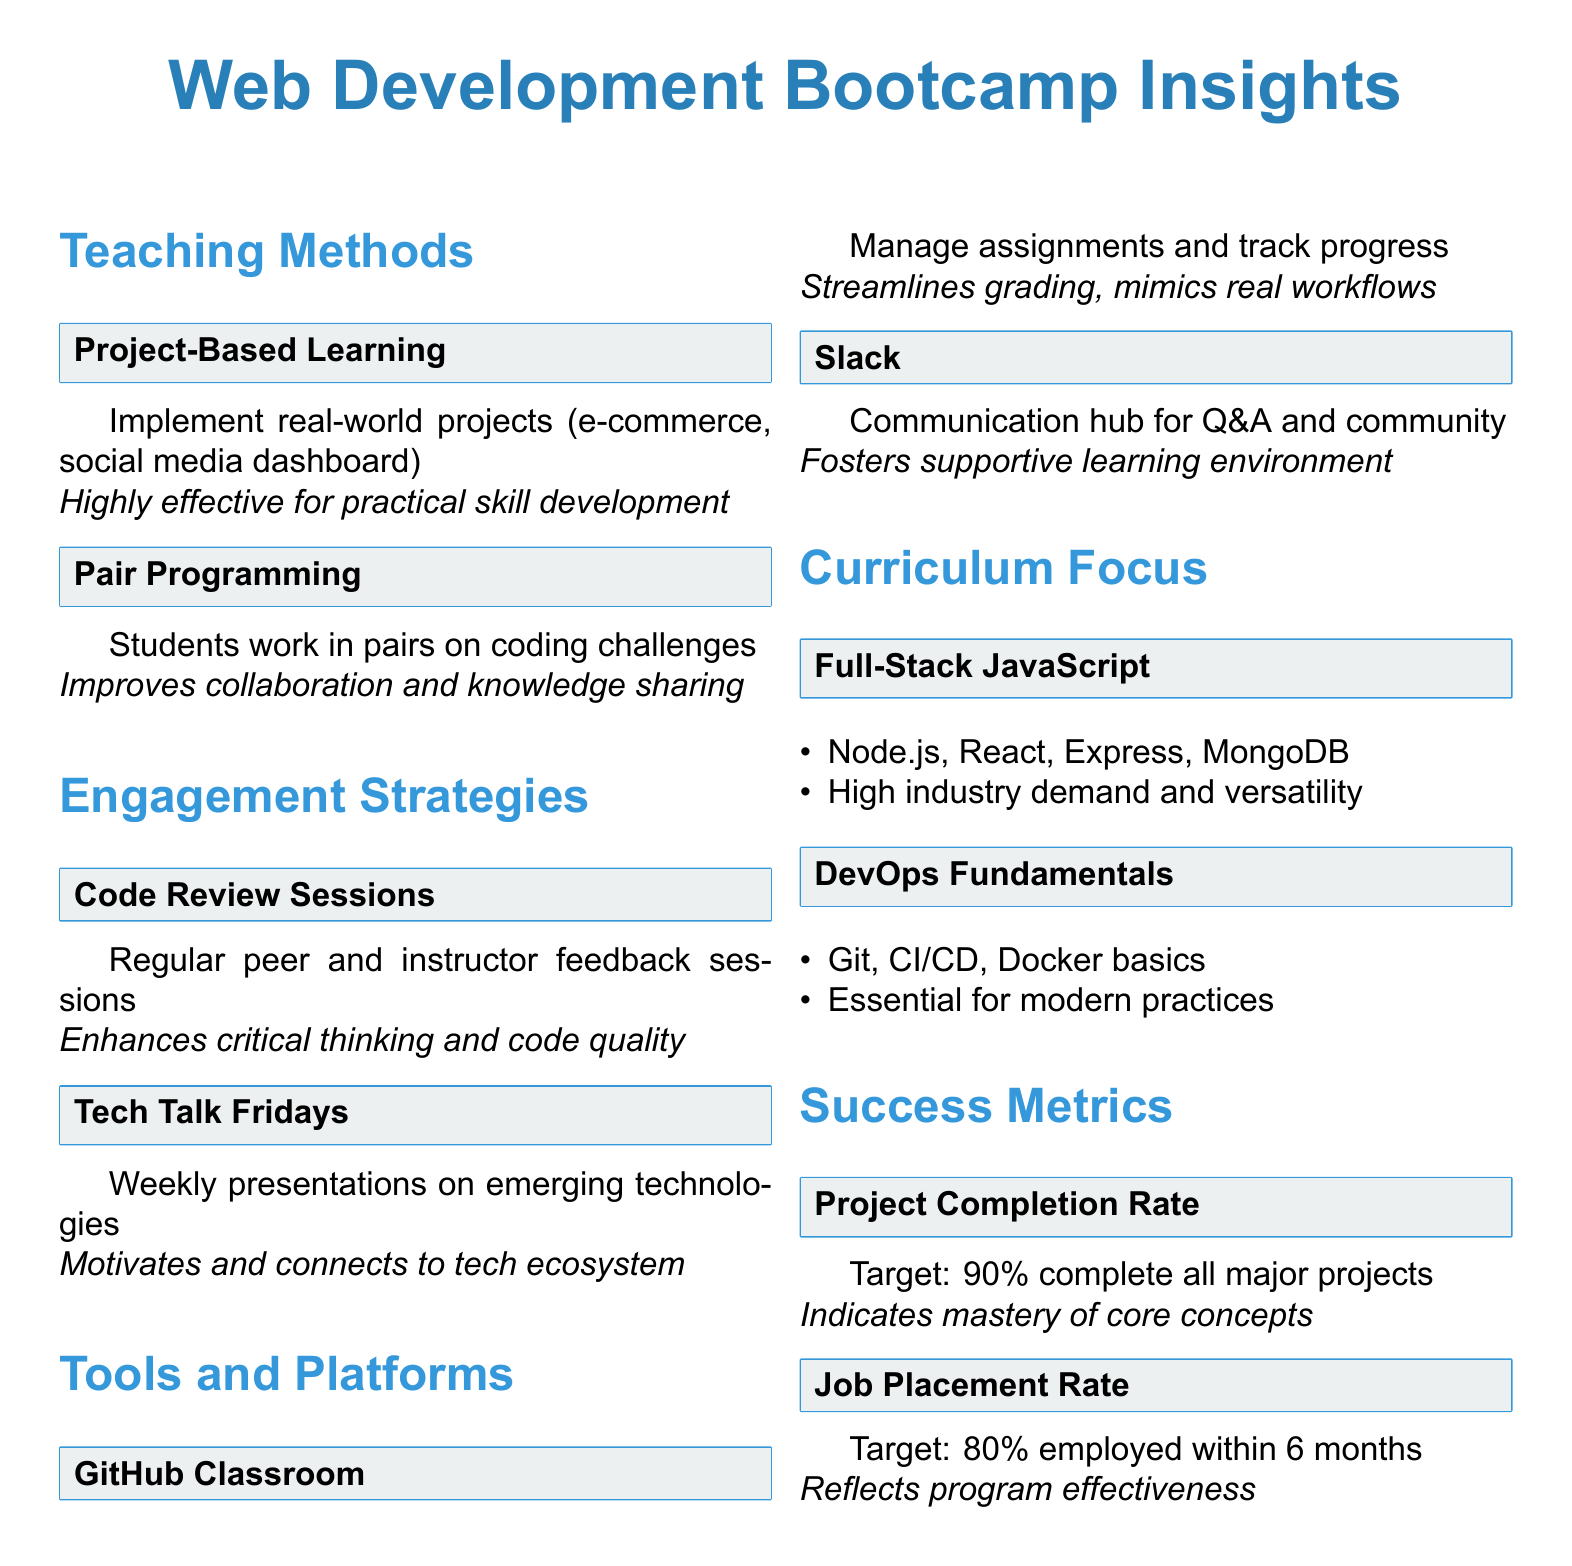What are the two teaching methods mentioned? The document outlines two teaching methods under the "Teaching Methods" section: Project-Based Learning and Pair Programming.
Answer: Project-Based Learning, Pair Programming What is the target for the Job Placement Rate? The Job Placement Rate section states the target for graduates employed within six months, which is 80%.
Answer: 80% What benefit do Code Review Sessions provide? The document describes that Code Review Sessions enhance critical thinking and code quality awareness.
Answer: Enhances critical thinking and code quality awareness Which communication tool is noted for fostering a supportive learning environment? In the Tools and Platforms section, Slack is mentioned as a communication hub that fosters a supportive learning environment.
Answer: Slack What is the key component of Full-Stack JavaScript focus? The curriculum focus for Full-Stack JavaScript includes important technologies, one of which is Node.js.
Answer: Node.js How many students should complete all major projects according to the Project Completion Rate? The target specified for Project Completion Rate indicates that 90% of students should complete all major projects.
Answer: 90% What is the primary rationale for including DevOps Fundamentals in the curriculum? The rationale highlights that DevOps Fundamentals are essential for modern web development practices and team collaboration.
Answer: Essential for modern practices What is a specific initiative of the engagement strategies? Tech Talk Fridays is a particular initiative aimed at keeping students motivated and connected to the broader tech ecosystem.
Answer: Tech Talk Fridays Which platform is used for managing assignments and tracking student progress? GitHub Classroom is identified in the Tools and Platforms section as the platform used for managing assignments and tracking progress.
Answer: GitHub Classroom 